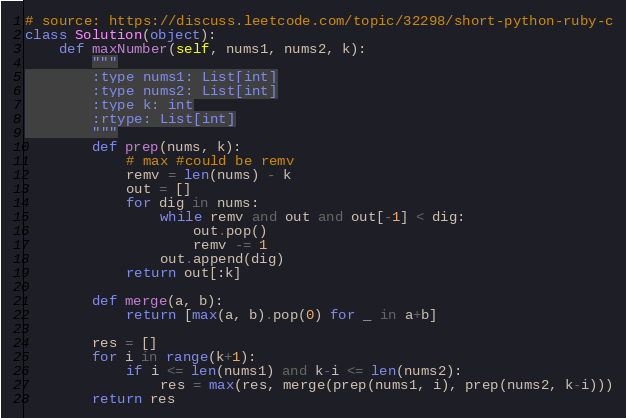<code> <loc_0><loc_0><loc_500><loc_500><_Python_># source: https://discuss.leetcode.com/topic/32298/short-python-ruby-c
class Solution(object):
    def maxNumber(self, nums1, nums2, k):
        """
        :type nums1: List[int]
        :type nums2: List[int]
        :type k: int
        :rtype: List[int]
        """
        def prep(nums, k):
            # max #could be remv
            remv = len(nums) - k
            out = []
            for dig in nums:
                while remv and out and out[-1] < dig:
                    out.pop()
                    remv -= 1
                out.append(dig)
            return out[:k]

        def merge(a, b):
            return [max(a, b).pop(0) for _ in a+b]

        res = []
        for i in range(k+1):
            if i <= len(nums1) and k-i <= len(nums2):
                res = max(res, merge(prep(nums1, i), prep(nums2, k-i)))
        return res
</code> 